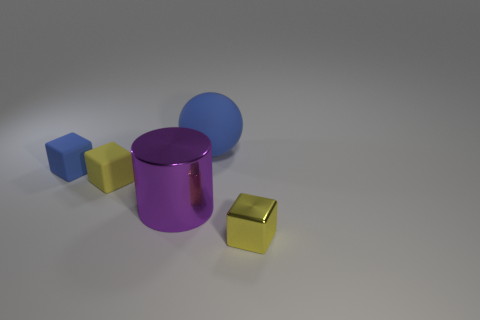Subtract all tiny yellow cubes. How many cubes are left? 1 Add 2 tiny shiny objects. How many objects exist? 7 Subtract all blue blocks. How many blocks are left? 2 Subtract 1 cylinders. How many cylinders are left? 0 Subtract all blue blocks. Subtract all blue balls. How many blocks are left? 2 Subtract all blue cylinders. How many purple blocks are left? 0 Subtract all tiny rubber objects. Subtract all large blue rubber cubes. How many objects are left? 3 Add 5 small metal things. How many small metal things are left? 6 Add 2 large spheres. How many large spheres exist? 3 Subtract 0 gray cubes. How many objects are left? 5 